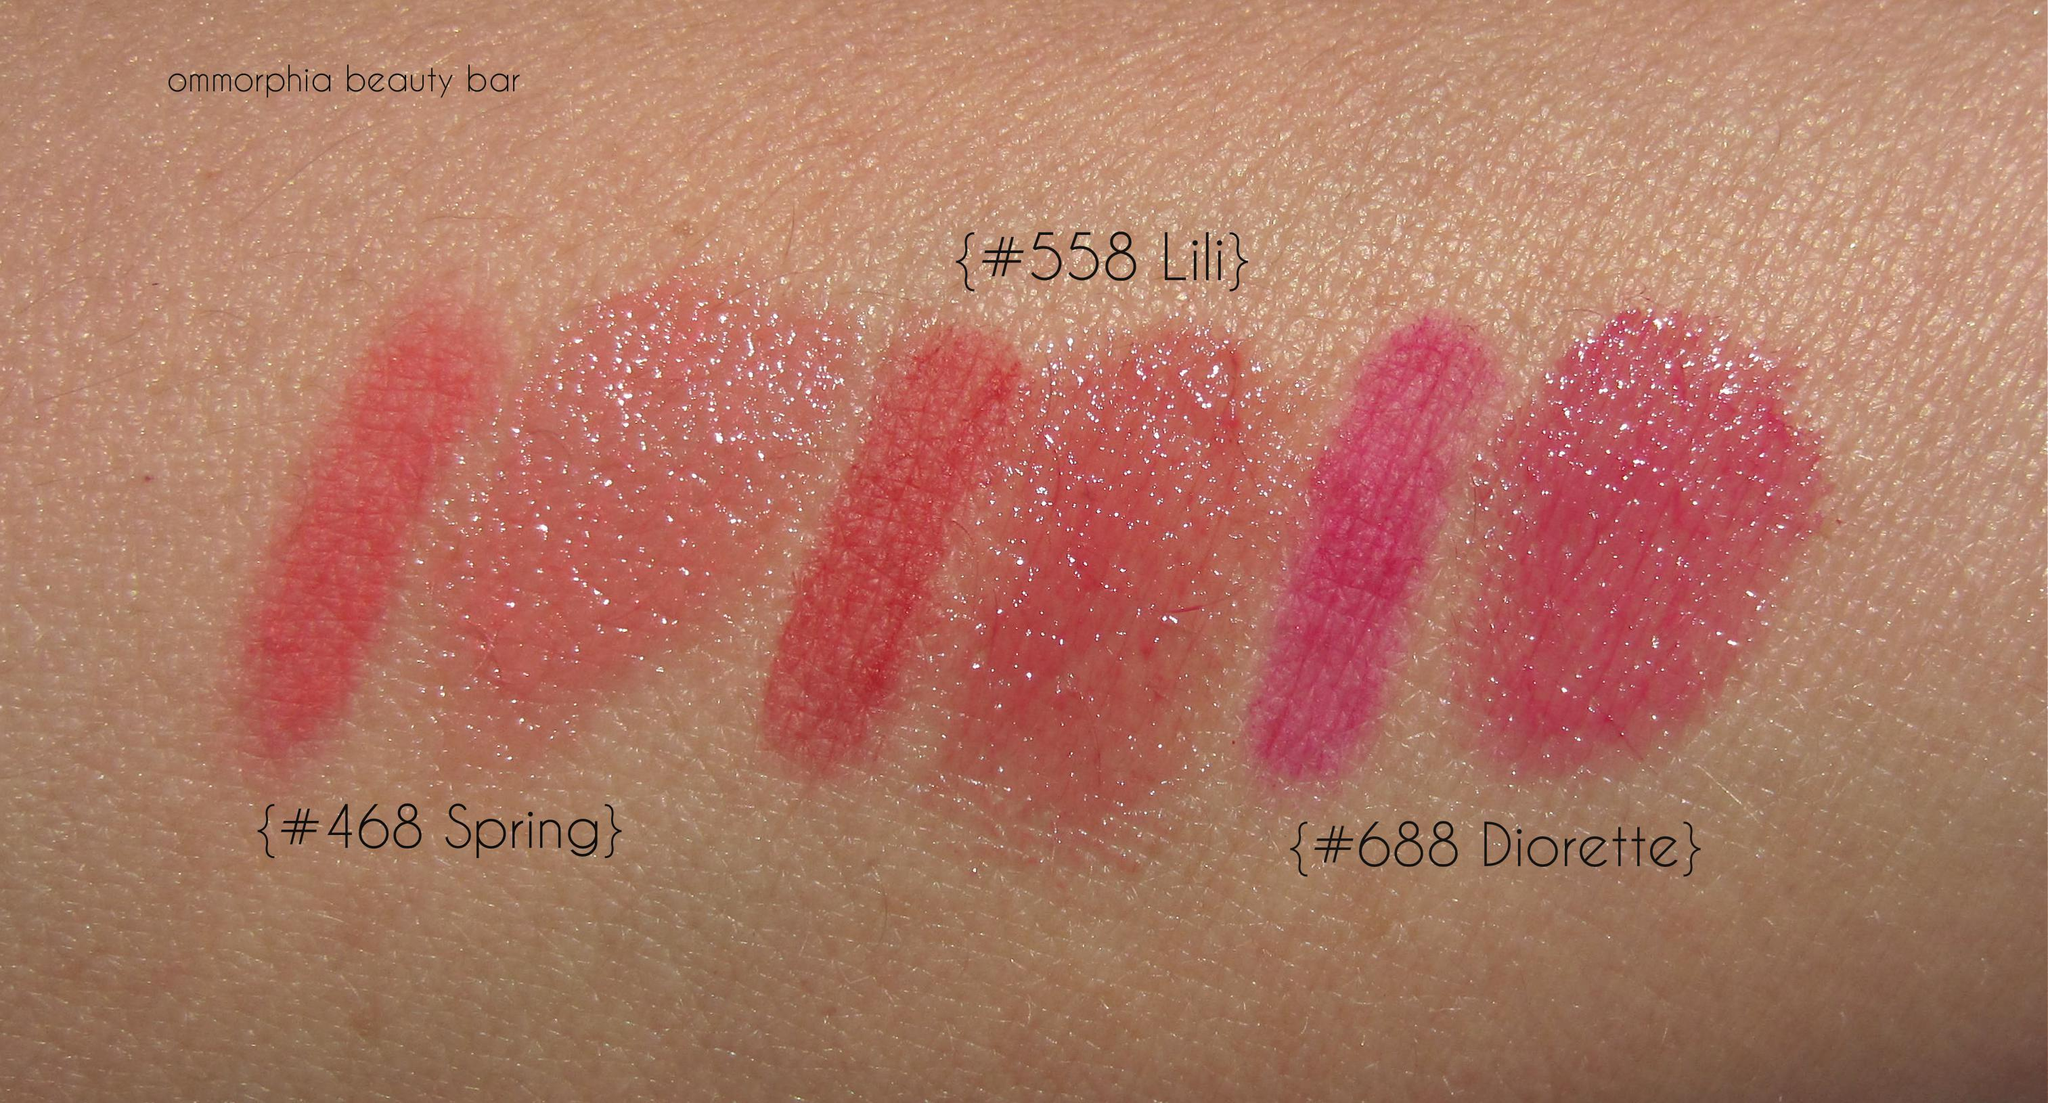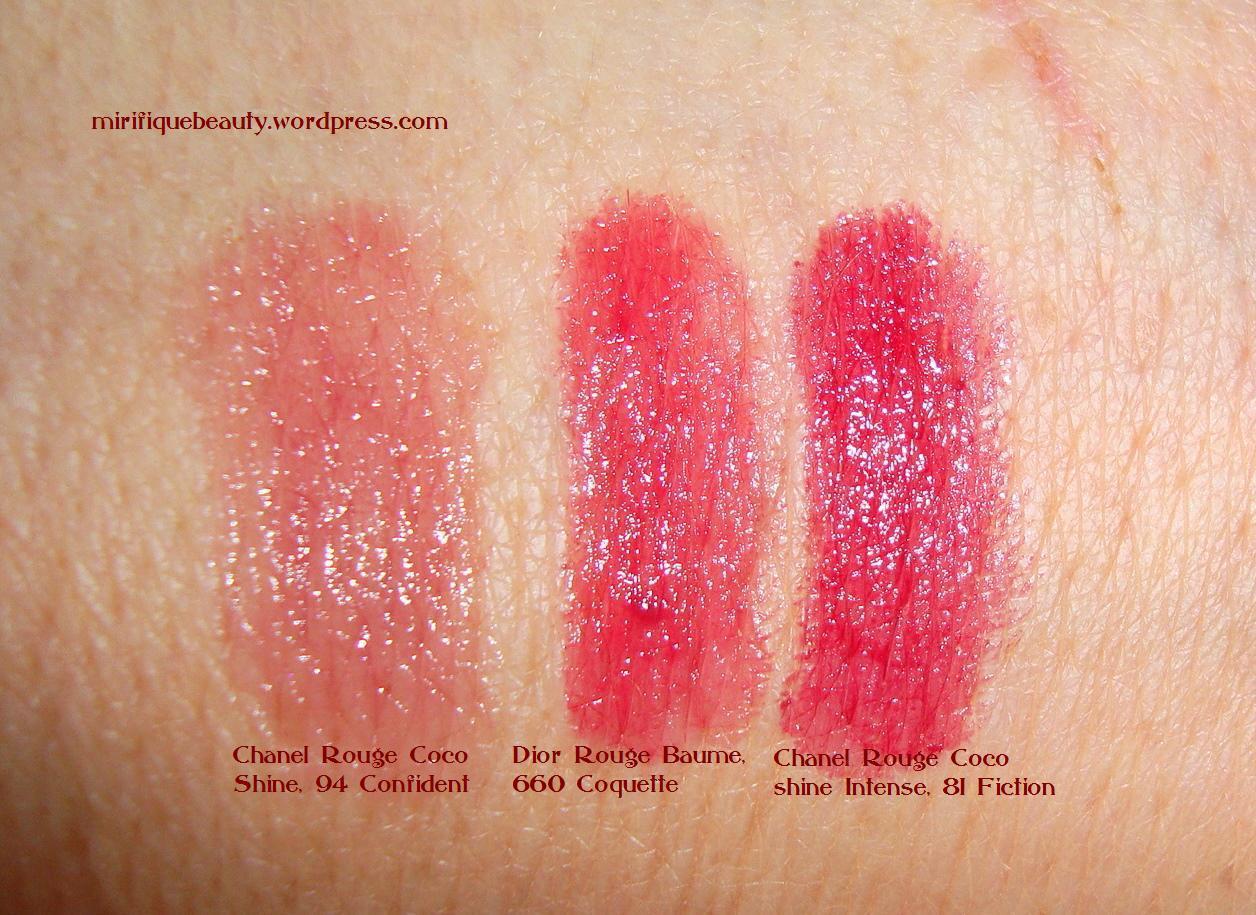The first image is the image on the left, the second image is the image on the right. For the images shown, is this caption "At least one of the images shows a woman's lips." true? Answer yes or no. No. The first image is the image on the left, the second image is the image on the right. Given the left and right images, does the statement "Atleast 1 pair of lips can be seen." hold true? Answer yes or no. No. 